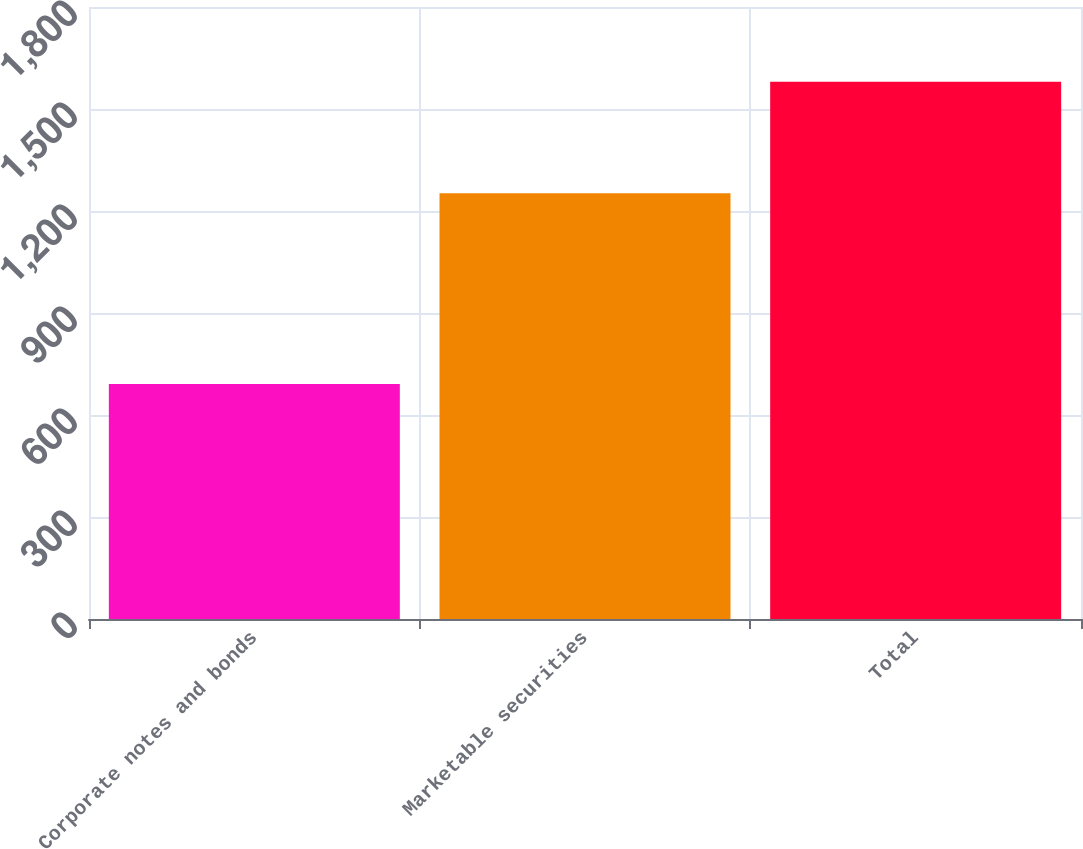<chart> <loc_0><loc_0><loc_500><loc_500><bar_chart><fcel>Corporate notes and bonds<fcel>Marketable securities<fcel>Total<nl><fcel>691<fcel>1252<fcel>1580<nl></chart> 